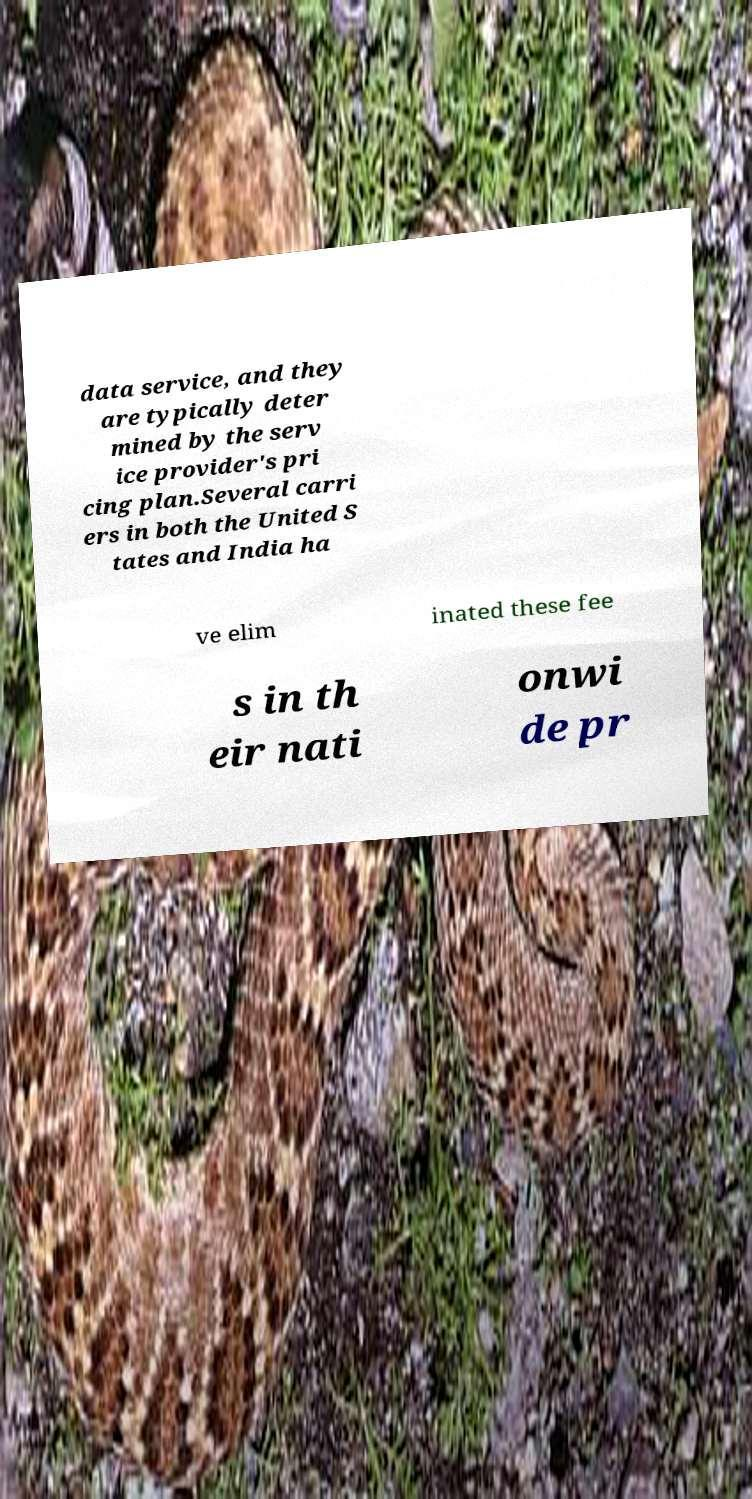Could you extract and type out the text from this image? data service, and they are typically deter mined by the serv ice provider's pri cing plan.Several carri ers in both the United S tates and India ha ve elim inated these fee s in th eir nati onwi de pr 